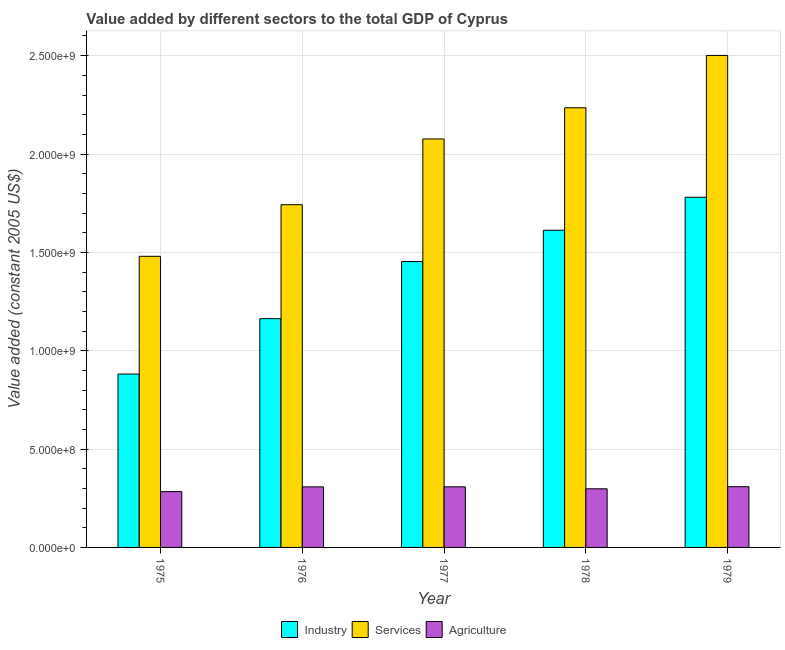How many different coloured bars are there?
Make the answer very short. 3. How many groups of bars are there?
Give a very brief answer. 5. Are the number of bars per tick equal to the number of legend labels?
Make the answer very short. Yes. How many bars are there on the 3rd tick from the left?
Keep it short and to the point. 3. How many bars are there on the 2nd tick from the right?
Keep it short and to the point. 3. What is the value added by services in 1977?
Ensure brevity in your answer.  2.08e+09. Across all years, what is the maximum value added by industrial sector?
Offer a terse response. 1.78e+09. Across all years, what is the minimum value added by industrial sector?
Your response must be concise. 8.81e+08. In which year was the value added by industrial sector maximum?
Offer a terse response. 1979. In which year was the value added by industrial sector minimum?
Give a very brief answer. 1975. What is the total value added by industrial sector in the graph?
Give a very brief answer. 6.89e+09. What is the difference between the value added by services in 1976 and that in 1979?
Offer a very short reply. -7.59e+08. What is the difference between the value added by services in 1977 and the value added by industrial sector in 1976?
Ensure brevity in your answer.  3.34e+08. What is the average value added by agricultural sector per year?
Keep it short and to the point. 3.01e+08. In the year 1979, what is the difference between the value added by agricultural sector and value added by services?
Offer a very short reply. 0. What is the ratio of the value added by agricultural sector in 1975 to that in 1979?
Ensure brevity in your answer.  0.92. Is the difference between the value added by services in 1975 and 1977 greater than the difference between the value added by industrial sector in 1975 and 1977?
Your answer should be compact. No. What is the difference between the highest and the second highest value added by services?
Keep it short and to the point. 2.66e+08. What is the difference between the highest and the lowest value added by services?
Provide a succinct answer. 1.02e+09. In how many years, is the value added by agricultural sector greater than the average value added by agricultural sector taken over all years?
Provide a short and direct response. 3. Is the sum of the value added by services in 1976 and 1978 greater than the maximum value added by agricultural sector across all years?
Make the answer very short. Yes. What does the 3rd bar from the left in 1979 represents?
Keep it short and to the point. Agriculture. What does the 2nd bar from the right in 1975 represents?
Provide a short and direct response. Services. What is the difference between two consecutive major ticks on the Y-axis?
Ensure brevity in your answer.  5.00e+08. Does the graph contain grids?
Give a very brief answer. Yes. Where does the legend appear in the graph?
Ensure brevity in your answer.  Bottom center. How are the legend labels stacked?
Offer a very short reply. Horizontal. What is the title of the graph?
Give a very brief answer. Value added by different sectors to the total GDP of Cyprus. Does "Interest" appear as one of the legend labels in the graph?
Keep it short and to the point. No. What is the label or title of the X-axis?
Keep it short and to the point. Year. What is the label or title of the Y-axis?
Keep it short and to the point. Value added (constant 2005 US$). What is the Value added (constant 2005 US$) in Industry in 1975?
Provide a short and direct response. 8.81e+08. What is the Value added (constant 2005 US$) in Services in 1975?
Offer a very short reply. 1.48e+09. What is the Value added (constant 2005 US$) in Agriculture in 1975?
Offer a terse response. 2.84e+08. What is the Value added (constant 2005 US$) in Industry in 1976?
Offer a terse response. 1.16e+09. What is the Value added (constant 2005 US$) of Services in 1976?
Provide a succinct answer. 1.74e+09. What is the Value added (constant 2005 US$) of Agriculture in 1976?
Your response must be concise. 3.08e+08. What is the Value added (constant 2005 US$) of Industry in 1977?
Keep it short and to the point. 1.45e+09. What is the Value added (constant 2005 US$) in Services in 1977?
Offer a terse response. 2.08e+09. What is the Value added (constant 2005 US$) in Agriculture in 1977?
Your response must be concise. 3.08e+08. What is the Value added (constant 2005 US$) of Industry in 1978?
Ensure brevity in your answer.  1.61e+09. What is the Value added (constant 2005 US$) in Services in 1978?
Your answer should be compact. 2.24e+09. What is the Value added (constant 2005 US$) in Agriculture in 1978?
Provide a succinct answer. 2.98e+08. What is the Value added (constant 2005 US$) of Industry in 1979?
Make the answer very short. 1.78e+09. What is the Value added (constant 2005 US$) in Services in 1979?
Provide a succinct answer. 2.50e+09. What is the Value added (constant 2005 US$) in Agriculture in 1979?
Give a very brief answer. 3.09e+08. Across all years, what is the maximum Value added (constant 2005 US$) in Industry?
Keep it short and to the point. 1.78e+09. Across all years, what is the maximum Value added (constant 2005 US$) of Services?
Provide a succinct answer. 2.50e+09. Across all years, what is the maximum Value added (constant 2005 US$) in Agriculture?
Your answer should be very brief. 3.09e+08. Across all years, what is the minimum Value added (constant 2005 US$) in Industry?
Ensure brevity in your answer.  8.81e+08. Across all years, what is the minimum Value added (constant 2005 US$) in Services?
Provide a succinct answer. 1.48e+09. Across all years, what is the minimum Value added (constant 2005 US$) in Agriculture?
Keep it short and to the point. 2.84e+08. What is the total Value added (constant 2005 US$) in Industry in the graph?
Your response must be concise. 6.89e+09. What is the total Value added (constant 2005 US$) of Services in the graph?
Ensure brevity in your answer.  1.00e+1. What is the total Value added (constant 2005 US$) in Agriculture in the graph?
Keep it short and to the point. 1.51e+09. What is the difference between the Value added (constant 2005 US$) in Industry in 1975 and that in 1976?
Provide a succinct answer. -2.82e+08. What is the difference between the Value added (constant 2005 US$) in Services in 1975 and that in 1976?
Offer a terse response. -2.62e+08. What is the difference between the Value added (constant 2005 US$) in Agriculture in 1975 and that in 1976?
Give a very brief answer. -2.40e+07. What is the difference between the Value added (constant 2005 US$) in Industry in 1975 and that in 1977?
Your response must be concise. -5.72e+08. What is the difference between the Value added (constant 2005 US$) in Services in 1975 and that in 1977?
Your answer should be very brief. -5.97e+08. What is the difference between the Value added (constant 2005 US$) in Agriculture in 1975 and that in 1977?
Ensure brevity in your answer.  -2.43e+07. What is the difference between the Value added (constant 2005 US$) of Industry in 1975 and that in 1978?
Ensure brevity in your answer.  -7.31e+08. What is the difference between the Value added (constant 2005 US$) of Services in 1975 and that in 1978?
Offer a very short reply. -7.55e+08. What is the difference between the Value added (constant 2005 US$) in Agriculture in 1975 and that in 1978?
Keep it short and to the point. -1.42e+07. What is the difference between the Value added (constant 2005 US$) of Industry in 1975 and that in 1979?
Your answer should be compact. -8.99e+08. What is the difference between the Value added (constant 2005 US$) in Services in 1975 and that in 1979?
Offer a terse response. -1.02e+09. What is the difference between the Value added (constant 2005 US$) in Agriculture in 1975 and that in 1979?
Ensure brevity in your answer.  -2.50e+07. What is the difference between the Value added (constant 2005 US$) in Industry in 1976 and that in 1977?
Give a very brief answer. -2.90e+08. What is the difference between the Value added (constant 2005 US$) of Services in 1976 and that in 1977?
Provide a succinct answer. -3.34e+08. What is the difference between the Value added (constant 2005 US$) of Agriculture in 1976 and that in 1977?
Make the answer very short. -3.16e+05. What is the difference between the Value added (constant 2005 US$) in Industry in 1976 and that in 1978?
Your answer should be very brief. -4.49e+08. What is the difference between the Value added (constant 2005 US$) in Services in 1976 and that in 1978?
Provide a short and direct response. -4.93e+08. What is the difference between the Value added (constant 2005 US$) of Agriculture in 1976 and that in 1978?
Keep it short and to the point. 9.80e+06. What is the difference between the Value added (constant 2005 US$) in Industry in 1976 and that in 1979?
Your answer should be compact. -6.17e+08. What is the difference between the Value added (constant 2005 US$) of Services in 1976 and that in 1979?
Offer a very short reply. -7.59e+08. What is the difference between the Value added (constant 2005 US$) in Agriculture in 1976 and that in 1979?
Provide a succinct answer. -9.48e+05. What is the difference between the Value added (constant 2005 US$) in Industry in 1977 and that in 1978?
Keep it short and to the point. -1.59e+08. What is the difference between the Value added (constant 2005 US$) in Services in 1977 and that in 1978?
Provide a succinct answer. -1.59e+08. What is the difference between the Value added (constant 2005 US$) in Agriculture in 1977 and that in 1978?
Your answer should be very brief. 1.01e+07. What is the difference between the Value added (constant 2005 US$) in Industry in 1977 and that in 1979?
Ensure brevity in your answer.  -3.27e+08. What is the difference between the Value added (constant 2005 US$) in Services in 1977 and that in 1979?
Offer a very short reply. -4.25e+08. What is the difference between the Value added (constant 2005 US$) of Agriculture in 1977 and that in 1979?
Provide a short and direct response. -6.32e+05. What is the difference between the Value added (constant 2005 US$) in Industry in 1978 and that in 1979?
Provide a succinct answer. -1.68e+08. What is the difference between the Value added (constant 2005 US$) in Services in 1978 and that in 1979?
Keep it short and to the point. -2.66e+08. What is the difference between the Value added (constant 2005 US$) of Agriculture in 1978 and that in 1979?
Keep it short and to the point. -1.07e+07. What is the difference between the Value added (constant 2005 US$) of Industry in 1975 and the Value added (constant 2005 US$) of Services in 1976?
Provide a succinct answer. -8.61e+08. What is the difference between the Value added (constant 2005 US$) in Industry in 1975 and the Value added (constant 2005 US$) in Agriculture in 1976?
Offer a very short reply. 5.73e+08. What is the difference between the Value added (constant 2005 US$) of Services in 1975 and the Value added (constant 2005 US$) of Agriculture in 1976?
Offer a terse response. 1.17e+09. What is the difference between the Value added (constant 2005 US$) of Industry in 1975 and the Value added (constant 2005 US$) of Services in 1977?
Your answer should be very brief. -1.20e+09. What is the difference between the Value added (constant 2005 US$) in Industry in 1975 and the Value added (constant 2005 US$) in Agriculture in 1977?
Offer a terse response. 5.73e+08. What is the difference between the Value added (constant 2005 US$) in Services in 1975 and the Value added (constant 2005 US$) in Agriculture in 1977?
Ensure brevity in your answer.  1.17e+09. What is the difference between the Value added (constant 2005 US$) in Industry in 1975 and the Value added (constant 2005 US$) in Services in 1978?
Provide a succinct answer. -1.35e+09. What is the difference between the Value added (constant 2005 US$) of Industry in 1975 and the Value added (constant 2005 US$) of Agriculture in 1978?
Provide a short and direct response. 5.83e+08. What is the difference between the Value added (constant 2005 US$) of Services in 1975 and the Value added (constant 2005 US$) of Agriculture in 1978?
Offer a terse response. 1.18e+09. What is the difference between the Value added (constant 2005 US$) in Industry in 1975 and the Value added (constant 2005 US$) in Services in 1979?
Ensure brevity in your answer.  -1.62e+09. What is the difference between the Value added (constant 2005 US$) in Industry in 1975 and the Value added (constant 2005 US$) in Agriculture in 1979?
Ensure brevity in your answer.  5.73e+08. What is the difference between the Value added (constant 2005 US$) of Services in 1975 and the Value added (constant 2005 US$) of Agriculture in 1979?
Make the answer very short. 1.17e+09. What is the difference between the Value added (constant 2005 US$) in Industry in 1976 and the Value added (constant 2005 US$) in Services in 1977?
Ensure brevity in your answer.  -9.14e+08. What is the difference between the Value added (constant 2005 US$) in Industry in 1976 and the Value added (constant 2005 US$) in Agriculture in 1977?
Ensure brevity in your answer.  8.55e+08. What is the difference between the Value added (constant 2005 US$) in Services in 1976 and the Value added (constant 2005 US$) in Agriculture in 1977?
Provide a succinct answer. 1.43e+09. What is the difference between the Value added (constant 2005 US$) of Industry in 1976 and the Value added (constant 2005 US$) of Services in 1978?
Offer a terse response. -1.07e+09. What is the difference between the Value added (constant 2005 US$) in Industry in 1976 and the Value added (constant 2005 US$) in Agriculture in 1978?
Your response must be concise. 8.65e+08. What is the difference between the Value added (constant 2005 US$) in Services in 1976 and the Value added (constant 2005 US$) in Agriculture in 1978?
Your answer should be compact. 1.44e+09. What is the difference between the Value added (constant 2005 US$) in Industry in 1976 and the Value added (constant 2005 US$) in Services in 1979?
Ensure brevity in your answer.  -1.34e+09. What is the difference between the Value added (constant 2005 US$) in Industry in 1976 and the Value added (constant 2005 US$) in Agriculture in 1979?
Make the answer very short. 8.54e+08. What is the difference between the Value added (constant 2005 US$) in Services in 1976 and the Value added (constant 2005 US$) in Agriculture in 1979?
Your answer should be very brief. 1.43e+09. What is the difference between the Value added (constant 2005 US$) of Industry in 1977 and the Value added (constant 2005 US$) of Services in 1978?
Your answer should be very brief. -7.82e+08. What is the difference between the Value added (constant 2005 US$) in Industry in 1977 and the Value added (constant 2005 US$) in Agriculture in 1978?
Keep it short and to the point. 1.16e+09. What is the difference between the Value added (constant 2005 US$) of Services in 1977 and the Value added (constant 2005 US$) of Agriculture in 1978?
Offer a terse response. 1.78e+09. What is the difference between the Value added (constant 2005 US$) in Industry in 1977 and the Value added (constant 2005 US$) in Services in 1979?
Offer a terse response. -1.05e+09. What is the difference between the Value added (constant 2005 US$) of Industry in 1977 and the Value added (constant 2005 US$) of Agriculture in 1979?
Ensure brevity in your answer.  1.14e+09. What is the difference between the Value added (constant 2005 US$) in Services in 1977 and the Value added (constant 2005 US$) in Agriculture in 1979?
Ensure brevity in your answer.  1.77e+09. What is the difference between the Value added (constant 2005 US$) of Industry in 1978 and the Value added (constant 2005 US$) of Services in 1979?
Make the answer very short. -8.89e+08. What is the difference between the Value added (constant 2005 US$) in Industry in 1978 and the Value added (constant 2005 US$) in Agriculture in 1979?
Offer a very short reply. 1.30e+09. What is the difference between the Value added (constant 2005 US$) in Services in 1978 and the Value added (constant 2005 US$) in Agriculture in 1979?
Provide a short and direct response. 1.93e+09. What is the average Value added (constant 2005 US$) of Industry per year?
Offer a very short reply. 1.38e+09. What is the average Value added (constant 2005 US$) of Services per year?
Keep it short and to the point. 2.01e+09. What is the average Value added (constant 2005 US$) in Agriculture per year?
Offer a terse response. 3.01e+08. In the year 1975, what is the difference between the Value added (constant 2005 US$) of Industry and Value added (constant 2005 US$) of Services?
Ensure brevity in your answer.  -5.99e+08. In the year 1975, what is the difference between the Value added (constant 2005 US$) in Industry and Value added (constant 2005 US$) in Agriculture?
Offer a very short reply. 5.97e+08. In the year 1975, what is the difference between the Value added (constant 2005 US$) of Services and Value added (constant 2005 US$) of Agriculture?
Provide a succinct answer. 1.20e+09. In the year 1976, what is the difference between the Value added (constant 2005 US$) of Industry and Value added (constant 2005 US$) of Services?
Provide a short and direct response. -5.79e+08. In the year 1976, what is the difference between the Value added (constant 2005 US$) of Industry and Value added (constant 2005 US$) of Agriculture?
Your answer should be very brief. 8.55e+08. In the year 1976, what is the difference between the Value added (constant 2005 US$) of Services and Value added (constant 2005 US$) of Agriculture?
Offer a terse response. 1.43e+09. In the year 1977, what is the difference between the Value added (constant 2005 US$) in Industry and Value added (constant 2005 US$) in Services?
Provide a short and direct response. -6.23e+08. In the year 1977, what is the difference between the Value added (constant 2005 US$) of Industry and Value added (constant 2005 US$) of Agriculture?
Offer a terse response. 1.15e+09. In the year 1977, what is the difference between the Value added (constant 2005 US$) of Services and Value added (constant 2005 US$) of Agriculture?
Your answer should be very brief. 1.77e+09. In the year 1978, what is the difference between the Value added (constant 2005 US$) in Industry and Value added (constant 2005 US$) in Services?
Ensure brevity in your answer.  -6.23e+08. In the year 1978, what is the difference between the Value added (constant 2005 US$) of Industry and Value added (constant 2005 US$) of Agriculture?
Offer a terse response. 1.31e+09. In the year 1978, what is the difference between the Value added (constant 2005 US$) of Services and Value added (constant 2005 US$) of Agriculture?
Keep it short and to the point. 1.94e+09. In the year 1979, what is the difference between the Value added (constant 2005 US$) in Industry and Value added (constant 2005 US$) in Services?
Ensure brevity in your answer.  -7.21e+08. In the year 1979, what is the difference between the Value added (constant 2005 US$) in Industry and Value added (constant 2005 US$) in Agriculture?
Your answer should be compact. 1.47e+09. In the year 1979, what is the difference between the Value added (constant 2005 US$) of Services and Value added (constant 2005 US$) of Agriculture?
Your response must be concise. 2.19e+09. What is the ratio of the Value added (constant 2005 US$) in Industry in 1975 to that in 1976?
Make the answer very short. 0.76. What is the ratio of the Value added (constant 2005 US$) in Services in 1975 to that in 1976?
Your response must be concise. 0.85. What is the ratio of the Value added (constant 2005 US$) in Agriculture in 1975 to that in 1976?
Give a very brief answer. 0.92. What is the ratio of the Value added (constant 2005 US$) of Industry in 1975 to that in 1977?
Offer a very short reply. 0.61. What is the ratio of the Value added (constant 2005 US$) in Services in 1975 to that in 1977?
Keep it short and to the point. 0.71. What is the ratio of the Value added (constant 2005 US$) in Agriculture in 1975 to that in 1977?
Keep it short and to the point. 0.92. What is the ratio of the Value added (constant 2005 US$) in Industry in 1975 to that in 1978?
Ensure brevity in your answer.  0.55. What is the ratio of the Value added (constant 2005 US$) of Services in 1975 to that in 1978?
Provide a short and direct response. 0.66. What is the ratio of the Value added (constant 2005 US$) of Agriculture in 1975 to that in 1978?
Offer a very short reply. 0.95. What is the ratio of the Value added (constant 2005 US$) in Industry in 1975 to that in 1979?
Ensure brevity in your answer.  0.5. What is the ratio of the Value added (constant 2005 US$) in Services in 1975 to that in 1979?
Provide a short and direct response. 0.59. What is the ratio of the Value added (constant 2005 US$) in Agriculture in 1975 to that in 1979?
Offer a very short reply. 0.92. What is the ratio of the Value added (constant 2005 US$) in Industry in 1976 to that in 1977?
Make the answer very short. 0.8. What is the ratio of the Value added (constant 2005 US$) in Services in 1976 to that in 1977?
Give a very brief answer. 0.84. What is the ratio of the Value added (constant 2005 US$) in Agriculture in 1976 to that in 1977?
Keep it short and to the point. 1. What is the ratio of the Value added (constant 2005 US$) of Industry in 1976 to that in 1978?
Provide a succinct answer. 0.72. What is the ratio of the Value added (constant 2005 US$) in Services in 1976 to that in 1978?
Your response must be concise. 0.78. What is the ratio of the Value added (constant 2005 US$) of Agriculture in 1976 to that in 1978?
Make the answer very short. 1.03. What is the ratio of the Value added (constant 2005 US$) of Industry in 1976 to that in 1979?
Provide a short and direct response. 0.65. What is the ratio of the Value added (constant 2005 US$) of Services in 1976 to that in 1979?
Offer a very short reply. 0.7. What is the ratio of the Value added (constant 2005 US$) of Industry in 1977 to that in 1978?
Provide a short and direct response. 0.9. What is the ratio of the Value added (constant 2005 US$) of Services in 1977 to that in 1978?
Provide a short and direct response. 0.93. What is the ratio of the Value added (constant 2005 US$) in Agriculture in 1977 to that in 1978?
Offer a terse response. 1.03. What is the ratio of the Value added (constant 2005 US$) in Industry in 1977 to that in 1979?
Make the answer very short. 0.82. What is the ratio of the Value added (constant 2005 US$) of Services in 1977 to that in 1979?
Offer a terse response. 0.83. What is the ratio of the Value added (constant 2005 US$) in Industry in 1978 to that in 1979?
Provide a short and direct response. 0.91. What is the ratio of the Value added (constant 2005 US$) in Services in 1978 to that in 1979?
Keep it short and to the point. 0.89. What is the ratio of the Value added (constant 2005 US$) of Agriculture in 1978 to that in 1979?
Ensure brevity in your answer.  0.97. What is the difference between the highest and the second highest Value added (constant 2005 US$) of Industry?
Your answer should be very brief. 1.68e+08. What is the difference between the highest and the second highest Value added (constant 2005 US$) of Services?
Keep it short and to the point. 2.66e+08. What is the difference between the highest and the second highest Value added (constant 2005 US$) of Agriculture?
Your answer should be very brief. 6.32e+05. What is the difference between the highest and the lowest Value added (constant 2005 US$) of Industry?
Make the answer very short. 8.99e+08. What is the difference between the highest and the lowest Value added (constant 2005 US$) of Services?
Your answer should be very brief. 1.02e+09. What is the difference between the highest and the lowest Value added (constant 2005 US$) in Agriculture?
Offer a very short reply. 2.50e+07. 